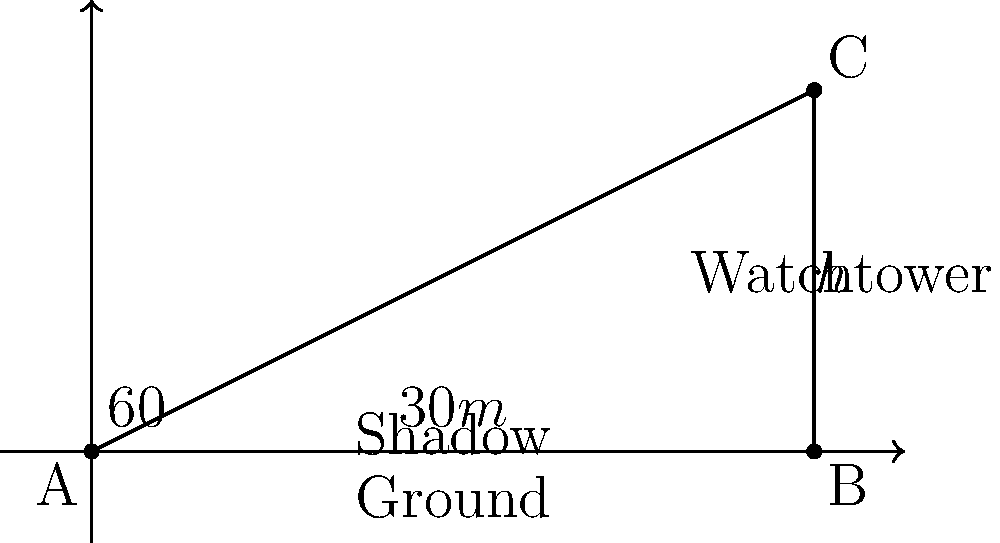As you're planning a culinary tour near a traditional Maltese watchtower, you notice its shadow stretches 30 meters on level ground. If the angle of elevation from the end of the shadow to the top of the tower is 60°, what is the height of the watchtower? Let's approach this step-by-step:

1) First, we can identify this as a right-angled triangle problem. The watchtower forms the vertical side (opposite to the 60° angle), the shadow forms the horizontal side (adjacent to the 60° angle), and the line from the end of the shadow to the top of the tower forms the hypotenuse.

2) We know:
   - The length of the shadow (adjacent side) is 30 meters
   - The angle of elevation is 60°

3) We need to find the height of the tower, which is the opposite side in relation to the 60° angle.

4) For this, we can use the tangent trigonometric ratio:

   $\tan \theta = \frac{\text{opposite}}{\text{adjacent}}$

5) Substituting our known values:

   $\tan 60° = \frac{h}{30}$

6) We know that $\tan 60° = \sqrt{3}$, so:

   $\sqrt{3} = \frac{h}{30}$

7) Solving for $h$:

   $h = 30 \sqrt{3}$

8) To get a decimal approximation:

   $h \approx 30 \times 1.732 \approx 51.96$ meters

Therefore, the height of the watchtower is approximately 51.96 meters.
Answer: $30\sqrt{3}$ meters (or approximately 51.96 meters) 